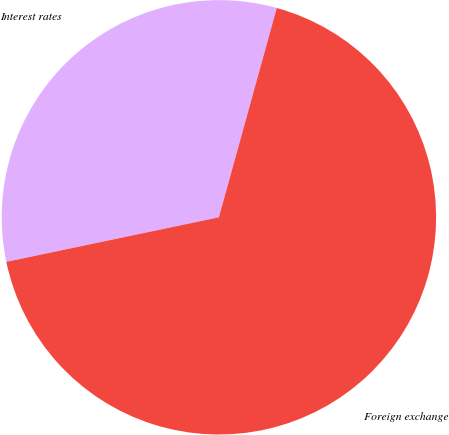Convert chart. <chart><loc_0><loc_0><loc_500><loc_500><pie_chart><fcel>Interest rates<fcel>Foreign exchange<nl><fcel>32.58%<fcel>67.42%<nl></chart> 